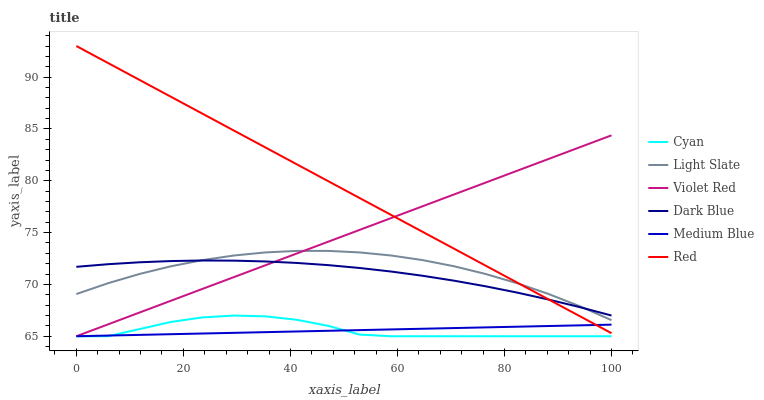Does Medium Blue have the minimum area under the curve?
Answer yes or no. Yes. Does Red have the maximum area under the curve?
Answer yes or no. Yes. Does Light Slate have the minimum area under the curve?
Answer yes or no. No. Does Light Slate have the maximum area under the curve?
Answer yes or no. No. Is Medium Blue the smoothest?
Answer yes or no. Yes. Is Cyan the roughest?
Answer yes or no. Yes. Is Light Slate the smoothest?
Answer yes or no. No. Is Light Slate the roughest?
Answer yes or no. No. Does Light Slate have the lowest value?
Answer yes or no. No. Does Red have the highest value?
Answer yes or no. Yes. Does Light Slate have the highest value?
Answer yes or no. No. Is Medium Blue less than Light Slate?
Answer yes or no. Yes. Is Red greater than Cyan?
Answer yes or no. Yes. Does Violet Red intersect Light Slate?
Answer yes or no. Yes. Is Violet Red less than Light Slate?
Answer yes or no. No. Is Violet Red greater than Light Slate?
Answer yes or no. No. Does Medium Blue intersect Light Slate?
Answer yes or no. No. 